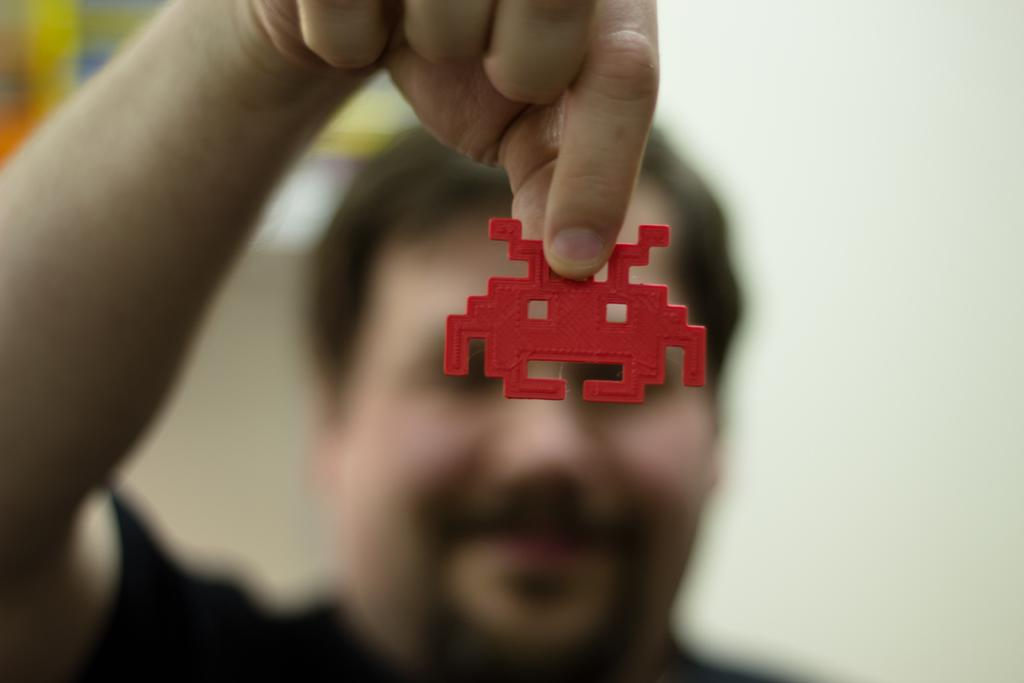What is present in the image? There is a man in the image. What is the man holding in the image? The man is holding a red object. What time is depicted in the image? The time is not depicted in the image, as it does not contain any elements that would indicate a specific time. 